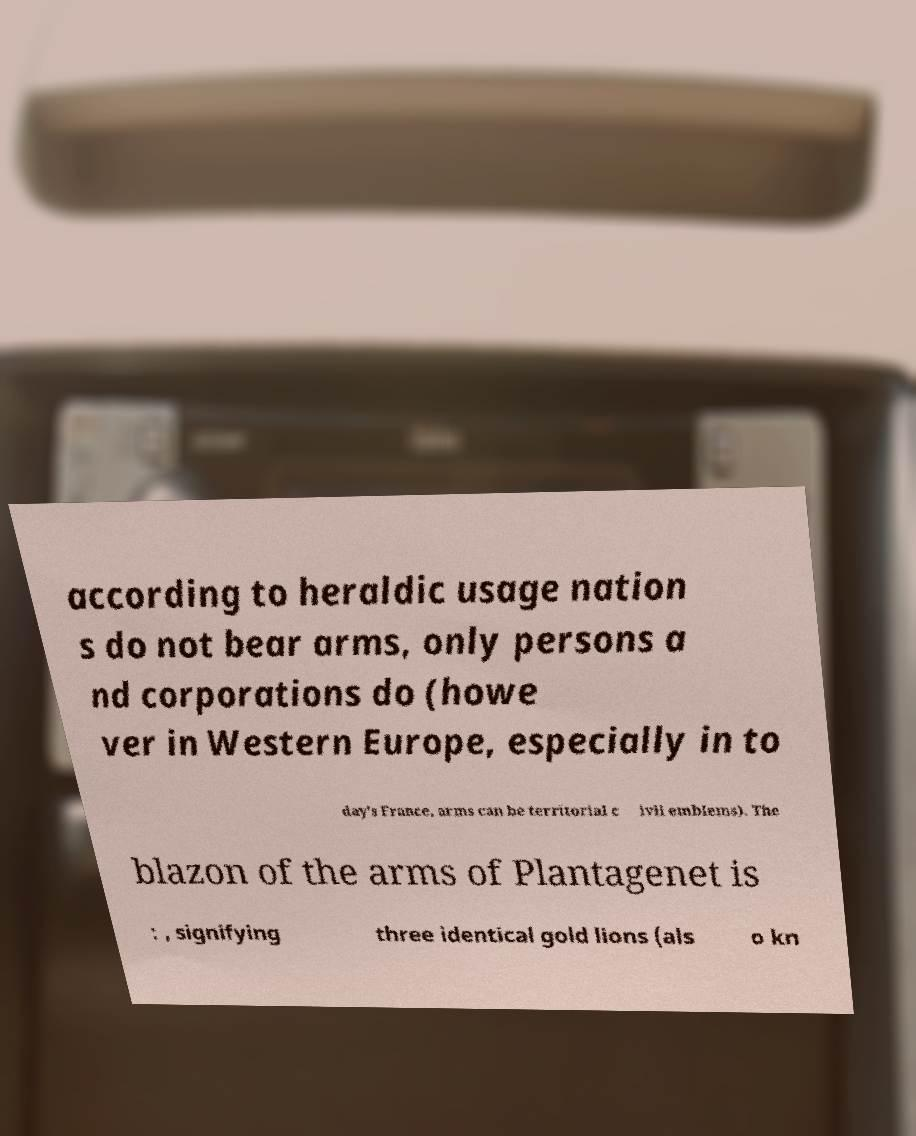I need the written content from this picture converted into text. Can you do that? according to heraldic usage nation s do not bear arms, only persons a nd corporations do (howe ver in Western Europe, especially in to day's France, arms can be territorial c ivil emblems). The blazon of the arms of Plantagenet is : , signifying three identical gold lions (als o kn 